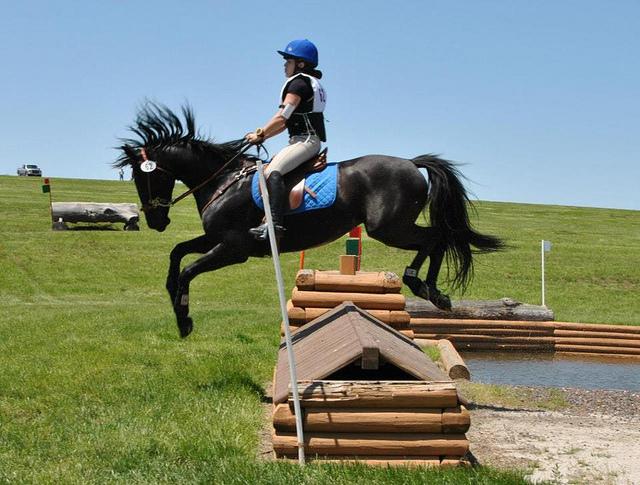Is it odd that the horse's mane is springing up, while nothing else indicates a strong breeze?
Short answer required. No. Is there water on the floor?
Keep it brief. Yes. What is the person riding?
Concise answer only. Horse. 